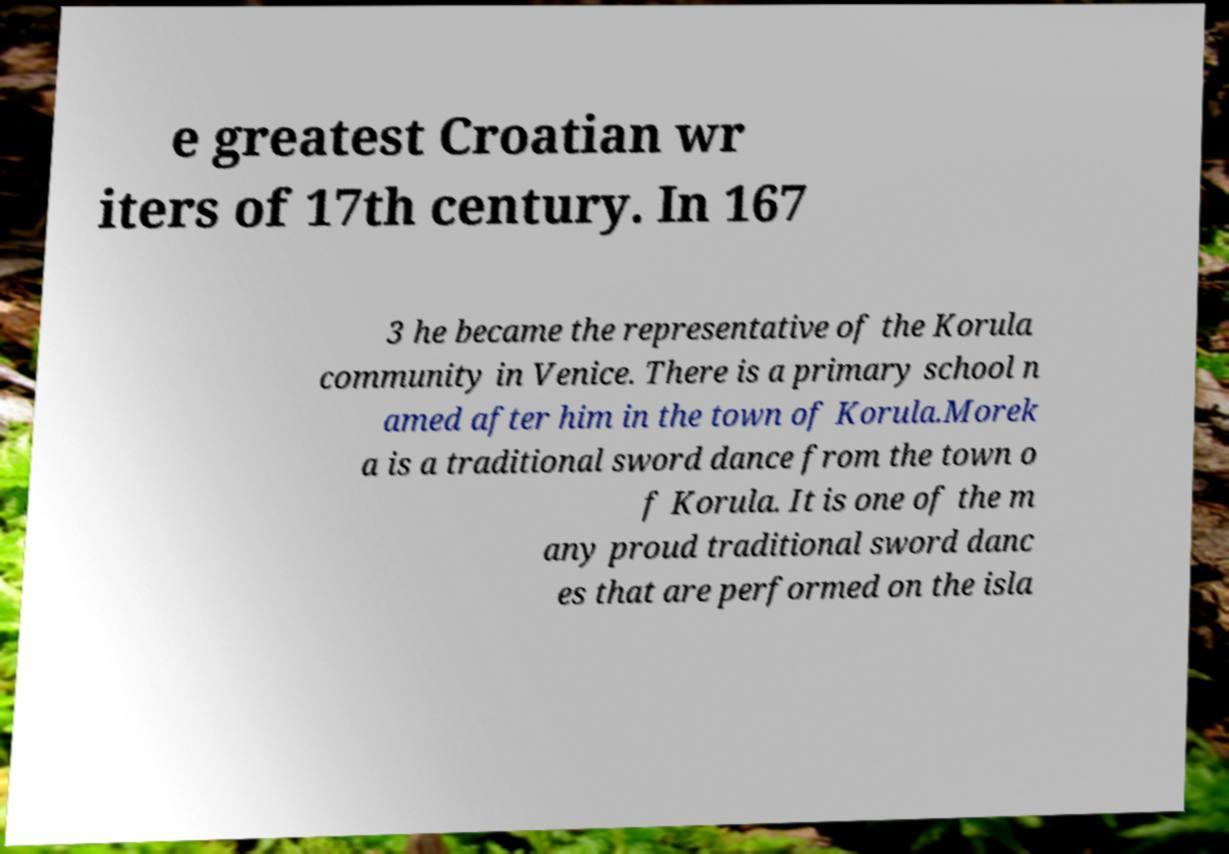Could you assist in decoding the text presented in this image and type it out clearly? e greatest Croatian wr iters of 17th century. In 167 3 he became the representative of the Korula community in Venice. There is a primary school n amed after him in the town of Korula.Morek a is a traditional sword dance from the town o f Korula. It is one of the m any proud traditional sword danc es that are performed on the isla 